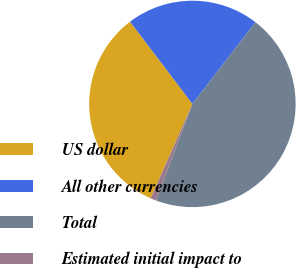<chart> <loc_0><loc_0><loc_500><loc_500><pie_chart><fcel>US dollar<fcel>All other currencies<fcel>Total<fcel>Estimated initial impact to<nl><fcel>33.04%<fcel>20.8%<fcel>45.28%<fcel>0.88%<nl></chart> 